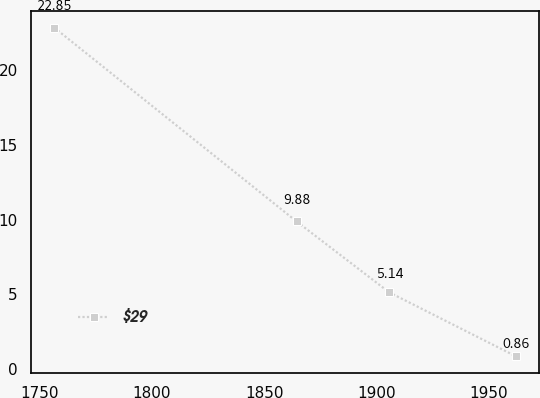Convert chart to OTSL. <chart><loc_0><loc_0><loc_500><loc_500><line_chart><ecel><fcel>$29<nl><fcel>1756.41<fcel>22.85<nl><fcel>1864.48<fcel>9.88<nl><fcel>1905.76<fcel>5.14<nl><fcel>1962.26<fcel>0.86<nl></chart> 